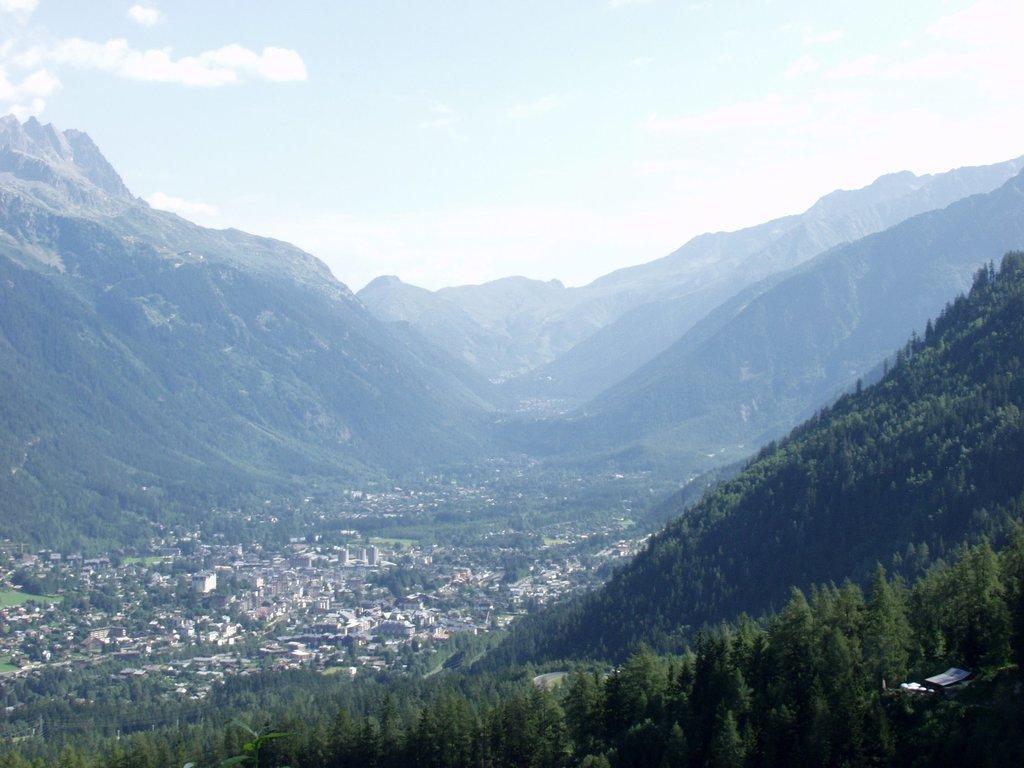Describe this image in one or two sentences. In this image we can see trees on the hills, houses, hills and the sky with clouds in the background. 